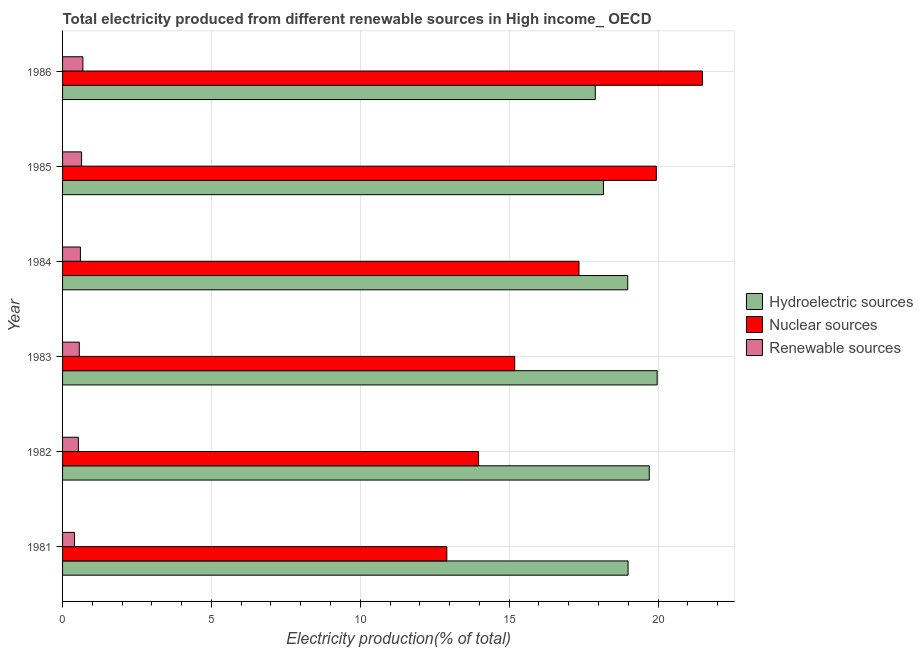How many different coloured bars are there?
Provide a short and direct response. 3. How many groups of bars are there?
Provide a succinct answer. 6. Are the number of bars on each tick of the Y-axis equal?
Provide a succinct answer. Yes. What is the label of the 3rd group of bars from the top?
Ensure brevity in your answer.  1984. In how many cases, is the number of bars for a given year not equal to the number of legend labels?
Make the answer very short. 0. What is the percentage of electricity produced by hydroelectric sources in 1984?
Provide a succinct answer. 18.98. Across all years, what is the maximum percentage of electricity produced by hydroelectric sources?
Your answer should be compact. 19.97. Across all years, what is the minimum percentage of electricity produced by renewable sources?
Provide a short and direct response. 0.4. What is the total percentage of electricity produced by renewable sources in the graph?
Make the answer very short. 3.41. What is the difference between the percentage of electricity produced by nuclear sources in 1981 and that in 1985?
Your response must be concise. -7.04. What is the difference between the percentage of electricity produced by nuclear sources in 1984 and the percentage of electricity produced by hydroelectric sources in 1983?
Your response must be concise. -2.63. What is the average percentage of electricity produced by renewable sources per year?
Your response must be concise. 0.57. In the year 1982, what is the difference between the percentage of electricity produced by renewable sources and percentage of electricity produced by hydroelectric sources?
Keep it short and to the point. -19.17. What is the ratio of the percentage of electricity produced by nuclear sources in 1981 to that in 1982?
Provide a short and direct response. 0.92. What is the difference between the highest and the second highest percentage of electricity produced by hydroelectric sources?
Your answer should be very brief. 0.27. What is the difference between the highest and the lowest percentage of electricity produced by hydroelectric sources?
Offer a very short reply. 2.08. What does the 1st bar from the top in 1986 represents?
Your response must be concise. Renewable sources. What does the 3rd bar from the bottom in 1981 represents?
Provide a short and direct response. Renewable sources. Is it the case that in every year, the sum of the percentage of electricity produced by hydroelectric sources and percentage of electricity produced by nuclear sources is greater than the percentage of electricity produced by renewable sources?
Your answer should be very brief. Yes. How many bars are there?
Make the answer very short. 18. Are all the bars in the graph horizontal?
Provide a short and direct response. Yes. How many years are there in the graph?
Give a very brief answer. 6. What is the difference between two consecutive major ticks on the X-axis?
Your answer should be very brief. 5. Are the values on the major ticks of X-axis written in scientific E-notation?
Make the answer very short. No. Does the graph contain grids?
Your answer should be very brief. Yes. How many legend labels are there?
Provide a short and direct response. 3. How are the legend labels stacked?
Offer a very short reply. Vertical. What is the title of the graph?
Offer a very short reply. Total electricity produced from different renewable sources in High income_ OECD. Does "Taxes on goods and services" appear as one of the legend labels in the graph?
Make the answer very short. No. What is the Electricity production(% of total) in Hydroelectric sources in 1981?
Your answer should be very brief. 18.99. What is the Electricity production(% of total) of Nuclear sources in 1981?
Your answer should be very brief. 12.91. What is the Electricity production(% of total) in Renewable sources in 1981?
Give a very brief answer. 0.4. What is the Electricity production(% of total) of Hydroelectric sources in 1982?
Your response must be concise. 19.7. What is the Electricity production(% of total) of Nuclear sources in 1982?
Offer a very short reply. 13.97. What is the Electricity production(% of total) in Renewable sources in 1982?
Your response must be concise. 0.53. What is the Electricity production(% of total) of Hydroelectric sources in 1983?
Your response must be concise. 19.97. What is the Electricity production(% of total) in Nuclear sources in 1983?
Provide a succinct answer. 15.19. What is the Electricity production(% of total) of Renewable sources in 1983?
Offer a terse response. 0.56. What is the Electricity production(% of total) in Hydroelectric sources in 1984?
Your response must be concise. 18.98. What is the Electricity production(% of total) in Nuclear sources in 1984?
Ensure brevity in your answer.  17.34. What is the Electricity production(% of total) in Renewable sources in 1984?
Make the answer very short. 0.6. What is the Electricity production(% of total) of Hydroelectric sources in 1985?
Keep it short and to the point. 18.17. What is the Electricity production(% of total) in Nuclear sources in 1985?
Provide a succinct answer. 19.94. What is the Electricity production(% of total) of Renewable sources in 1985?
Your response must be concise. 0.64. What is the Electricity production(% of total) of Hydroelectric sources in 1986?
Your answer should be compact. 17.89. What is the Electricity production(% of total) of Nuclear sources in 1986?
Offer a terse response. 21.49. What is the Electricity production(% of total) of Renewable sources in 1986?
Offer a terse response. 0.68. Across all years, what is the maximum Electricity production(% of total) of Hydroelectric sources?
Make the answer very short. 19.97. Across all years, what is the maximum Electricity production(% of total) in Nuclear sources?
Your answer should be very brief. 21.49. Across all years, what is the maximum Electricity production(% of total) in Renewable sources?
Keep it short and to the point. 0.68. Across all years, what is the minimum Electricity production(% of total) of Hydroelectric sources?
Provide a short and direct response. 17.89. Across all years, what is the minimum Electricity production(% of total) of Nuclear sources?
Provide a succinct answer. 12.91. Across all years, what is the minimum Electricity production(% of total) in Renewable sources?
Keep it short and to the point. 0.4. What is the total Electricity production(% of total) in Hydroelectric sources in the graph?
Offer a very short reply. 113.71. What is the total Electricity production(% of total) of Nuclear sources in the graph?
Provide a succinct answer. 100.84. What is the total Electricity production(% of total) of Renewable sources in the graph?
Your response must be concise. 3.41. What is the difference between the Electricity production(% of total) of Hydroelectric sources in 1981 and that in 1982?
Provide a short and direct response. -0.71. What is the difference between the Electricity production(% of total) in Nuclear sources in 1981 and that in 1982?
Provide a succinct answer. -1.07. What is the difference between the Electricity production(% of total) in Renewable sources in 1981 and that in 1982?
Your answer should be compact. -0.13. What is the difference between the Electricity production(% of total) in Hydroelectric sources in 1981 and that in 1983?
Give a very brief answer. -0.98. What is the difference between the Electricity production(% of total) in Nuclear sources in 1981 and that in 1983?
Your answer should be very brief. -2.28. What is the difference between the Electricity production(% of total) of Renewable sources in 1981 and that in 1983?
Provide a succinct answer. -0.16. What is the difference between the Electricity production(% of total) of Hydroelectric sources in 1981 and that in 1984?
Keep it short and to the point. 0.01. What is the difference between the Electricity production(% of total) of Nuclear sources in 1981 and that in 1984?
Provide a short and direct response. -4.44. What is the difference between the Electricity production(% of total) of Renewable sources in 1981 and that in 1984?
Offer a terse response. -0.2. What is the difference between the Electricity production(% of total) in Hydroelectric sources in 1981 and that in 1985?
Your answer should be compact. 0.83. What is the difference between the Electricity production(% of total) of Nuclear sources in 1981 and that in 1985?
Your answer should be very brief. -7.04. What is the difference between the Electricity production(% of total) in Renewable sources in 1981 and that in 1985?
Provide a succinct answer. -0.24. What is the difference between the Electricity production(% of total) of Hydroelectric sources in 1981 and that in 1986?
Ensure brevity in your answer.  1.1. What is the difference between the Electricity production(% of total) of Nuclear sources in 1981 and that in 1986?
Keep it short and to the point. -8.59. What is the difference between the Electricity production(% of total) of Renewable sources in 1981 and that in 1986?
Your response must be concise. -0.28. What is the difference between the Electricity production(% of total) of Hydroelectric sources in 1982 and that in 1983?
Offer a terse response. -0.27. What is the difference between the Electricity production(% of total) of Nuclear sources in 1982 and that in 1983?
Your response must be concise. -1.21. What is the difference between the Electricity production(% of total) in Renewable sources in 1982 and that in 1983?
Offer a terse response. -0.03. What is the difference between the Electricity production(% of total) of Hydroelectric sources in 1982 and that in 1984?
Make the answer very short. 0.72. What is the difference between the Electricity production(% of total) of Nuclear sources in 1982 and that in 1984?
Your answer should be very brief. -3.37. What is the difference between the Electricity production(% of total) of Renewable sources in 1982 and that in 1984?
Provide a succinct answer. -0.07. What is the difference between the Electricity production(% of total) in Hydroelectric sources in 1982 and that in 1985?
Ensure brevity in your answer.  1.54. What is the difference between the Electricity production(% of total) in Nuclear sources in 1982 and that in 1985?
Offer a very short reply. -5.97. What is the difference between the Electricity production(% of total) in Renewable sources in 1982 and that in 1985?
Provide a short and direct response. -0.11. What is the difference between the Electricity production(% of total) in Hydroelectric sources in 1982 and that in 1986?
Provide a short and direct response. 1.81. What is the difference between the Electricity production(% of total) in Nuclear sources in 1982 and that in 1986?
Your answer should be very brief. -7.52. What is the difference between the Electricity production(% of total) in Renewable sources in 1982 and that in 1986?
Make the answer very short. -0.15. What is the difference between the Electricity production(% of total) of Hydroelectric sources in 1983 and that in 1984?
Offer a terse response. 0.99. What is the difference between the Electricity production(% of total) of Nuclear sources in 1983 and that in 1984?
Your answer should be very brief. -2.16. What is the difference between the Electricity production(% of total) of Renewable sources in 1983 and that in 1984?
Your answer should be compact. -0.04. What is the difference between the Electricity production(% of total) in Hydroelectric sources in 1983 and that in 1985?
Keep it short and to the point. 1.8. What is the difference between the Electricity production(% of total) of Nuclear sources in 1983 and that in 1985?
Give a very brief answer. -4.76. What is the difference between the Electricity production(% of total) in Renewable sources in 1983 and that in 1985?
Offer a very short reply. -0.08. What is the difference between the Electricity production(% of total) of Hydroelectric sources in 1983 and that in 1986?
Give a very brief answer. 2.08. What is the difference between the Electricity production(% of total) of Nuclear sources in 1983 and that in 1986?
Your answer should be compact. -6.3. What is the difference between the Electricity production(% of total) of Renewable sources in 1983 and that in 1986?
Give a very brief answer. -0.12. What is the difference between the Electricity production(% of total) of Hydroelectric sources in 1984 and that in 1985?
Keep it short and to the point. 0.82. What is the difference between the Electricity production(% of total) of Nuclear sources in 1984 and that in 1985?
Give a very brief answer. -2.6. What is the difference between the Electricity production(% of total) of Renewable sources in 1984 and that in 1985?
Give a very brief answer. -0.04. What is the difference between the Electricity production(% of total) in Hydroelectric sources in 1984 and that in 1986?
Provide a succinct answer. 1.09. What is the difference between the Electricity production(% of total) of Nuclear sources in 1984 and that in 1986?
Your response must be concise. -4.15. What is the difference between the Electricity production(% of total) of Renewable sources in 1984 and that in 1986?
Your answer should be very brief. -0.08. What is the difference between the Electricity production(% of total) of Hydroelectric sources in 1985 and that in 1986?
Give a very brief answer. 0.27. What is the difference between the Electricity production(% of total) of Nuclear sources in 1985 and that in 1986?
Provide a succinct answer. -1.55. What is the difference between the Electricity production(% of total) of Renewable sources in 1985 and that in 1986?
Your answer should be very brief. -0.04. What is the difference between the Electricity production(% of total) in Hydroelectric sources in 1981 and the Electricity production(% of total) in Nuclear sources in 1982?
Offer a terse response. 5.02. What is the difference between the Electricity production(% of total) of Hydroelectric sources in 1981 and the Electricity production(% of total) of Renewable sources in 1982?
Keep it short and to the point. 18.46. What is the difference between the Electricity production(% of total) in Nuclear sources in 1981 and the Electricity production(% of total) in Renewable sources in 1982?
Your response must be concise. 12.38. What is the difference between the Electricity production(% of total) of Hydroelectric sources in 1981 and the Electricity production(% of total) of Nuclear sources in 1983?
Offer a terse response. 3.81. What is the difference between the Electricity production(% of total) in Hydroelectric sources in 1981 and the Electricity production(% of total) in Renewable sources in 1983?
Give a very brief answer. 18.43. What is the difference between the Electricity production(% of total) in Nuclear sources in 1981 and the Electricity production(% of total) in Renewable sources in 1983?
Give a very brief answer. 12.34. What is the difference between the Electricity production(% of total) of Hydroelectric sources in 1981 and the Electricity production(% of total) of Nuclear sources in 1984?
Offer a very short reply. 1.65. What is the difference between the Electricity production(% of total) in Hydroelectric sources in 1981 and the Electricity production(% of total) in Renewable sources in 1984?
Offer a very short reply. 18.39. What is the difference between the Electricity production(% of total) in Nuclear sources in 1981 and the Electricity production(% of total) in Renewable sources in 1984?
Provide a succinct answer. 12.31. What is the difference between the Electricity production(% of total) in Hydroelectric sources in 1981 and the Electricity production(% of total) in Nuclear sources in 1985?
Make the answer very short. -0.95. What is the difference between the Electricity production(% of total) in Hydroelectric sources in 1981 and the Electricity production(% of total) in Renewable sources in 1985?
Give a very brief answer. 18.35. What is the difference between the Electricity production(% of total) in Nuclear sources in 1981 and the Electricity production(% of total) in Renewable sources in 1985?
Ensure brevity in your answer.  12.27. What is the difference between the Electricity production(% of total) of Hydroelectric sources in 1981 and the Electricity production(% of total) of Nuclear sources in 1986?
Provide a short and direct response. -2.5. What is the difference between the Electricity production(% of total) in Hydroelectric sources in 1981 and the Electricity production(% of total) in Renewable sources in 1986?
Give a very brief answer. 18.31. What is the difference between the Electricity production(% of total) of Nuclear sources in 1981 and the Electricity production(% of total) of Renewable sources in 1986?
Your answer should be very brief. 12.22. What is the difference between the Electricity production(% of total) of Hydroelectric sources in 1982 and the Electricity production(% of total) of Nuclear sources in 1983?
Your answer should be compact. 4.52. What is the difference between the Electricity production(% of total) in Hydroelectric sources in 1982 and the Electricity production(% of total) in Renewable sources in 1983?
Provide a short and direct response. 19.14. What is the difference between the Electricity production(% of total) in Nuclear sources in 1982 and the Electricity production(% of total) in Renewable sources in 1983?
Make the answer very short. 13.41. What is the difference between the Electricity production(% of total) in Hydroelectric sources in 1982 and the Electricity production(% of total) in Nuclear sources in 1984?
Provide a succinct answer. 2.36. What is the difference between the Electricity production(% of total) in Hydroelectric sources in 1982 and the Electricity production(% of total) in Renewable sources in 1984?
Ensure brevity in your answer.  19.11. What is the difference between the Electricity production(% of total) in Nuclear sources in 1982 and the Electricity production(% of total) in Renewable sources in 1984?
Your answer should be very brief. 13.37. What is the difference between the Electricity production(% of total) of Hydroelectric sources in 1982 and the Electricity production(% of total) of Nuclear sources in 1985?
Ensure brevity in your answer.  -0.24. What is the difference between the Electricity production(% of total) in Hydroelectric sources in 1982 and the Electricity production(% of total) in Renewable sources in 1985?
Keep it short and to the point. 19.07. What is the difference between the Electricity production(% of total) in Nuclear sources in 1982 and the Electricity production(% of total) in Renewable sources in 1985?
Your answer should be very brief. 13.33. What is the difference between the Electricity production(% of total) of Hydroelectric sources in 1982 and the Electricity production(% of total) of Nuclear sources in 1986?
Your answer should be very brief. -1.79. What is the difference between the Electricity production(% of total) of Hydroelectric sources in 1982 and the Electricity production(% of total) of Renewable sources in 1986?
Provide a succinct answer. 19.02. What is the difference between the Electricity production(% of total) of Nuclear sources in 1982 and the Electricity production(% of total) of Renewable sources in 1986?
Ensure brevity in your answer.  13.29. What is the difference between the Electricity production(% of total) in Hydroelectric sources in 1983 and the Electricity production(% of total) in Nuclear sources in 1984?
Give a very brief answer. 2.63. What is the difference between the Electricity production(% of total) of Hydroelectric sources in 1983 and the Electricity production(% of total) of Renewable sources in 1984?
Your answer should be very brief. 19.37. What is the difference between the Electricity production(% of total) of Nuclear sources in 1983 and the Electricity production(% of total) of Renewable sources in 1984?
Keep it short and to the point. 14.59. What is the difference between the Electricity production(% of total) of Hydroelectric sources in 1983 and the Electricity production(% of total) of Nuclear sources in 1985?
Ensure brevity in your answer.  0.03. What is the difference between the Electricity production(% of total) in Hydroelectric sources in 1983 and the Electricity production(% of total) in Renewable sources in 1985?
Offer a very short reply. 19.33. What is the difference between the Electricity production(% of total) in Nuclear sources in 1983 and the Electricity production(% of total) in Renewable sources in 1985?
Your response must be concise. 14.55. What is the difference between the Electricity production(% of total) in Hydroelectric sources in 1983 and the Electricity production(% of total) in Nuclear sources in 1986?
Give a very brief answer. -1.52. What is the difference between the Electricity production(% of total) of Hydroelectric sources in 1983 and the Electricity production(% of total) of Renewable sources in 1986?
Offer a terse response. 19.29. What is the difference between the Electricity production(% of total) in Nuclear sources in 1983 and the Electricity production(% of total) in Renewable sources in 1986?
Your answer should be very brief. 14.5. What is the difference between the Electricity production(% of total) in Hydroelectric sources in 1984 and the Electricity production(% of total) in Nuclear sources in 1985?
Your response must be concise. -0.96. What is the difference between the Electricity production(% of total) of Hydroelectric sources in 1984 and the Electricity production(% of total) of Renewable sources in 1985?
Offer a very short reply. 18.34. What is the difference between the Electricity production(% of total) in Nuclear sources in 1984 and the Electricity production(% of total) in Renewable sources in 1985?
Your response must be concise. 16.71. What is the difference between the Electricity production(% of total) of Hydroelectric sources in 1984 and the Electricity production(% of total) of Nuclear sources in 1986?
Your answer should be very brief. -2.51. What is the difference between the Electricity production(% of total) in Hydroelectric sources in 1984 and the Electricity production(% of total) in Renewable sources in 1986?
Offer a terse response. 18.3. What is the difference between the Electricity production(% of total) in Nuclear sources in 1984 and the Electricity production(% of total) in Renewable sources in 1986?
Give a very brief answer. 16.66. What is the difference between the Electricity production(% of total) of Hydroelectric sources in 1985 and the Electricity production(% of total) of Nuclear sources in 1986?
Keep it short and to the point. -3.32. What is the difference between the Electricity production(% of total) in Hydroelectric sources in 1985 and the Electricity production(% of total) in Renewable sources in 1986?
Make the answer very short. 17.48. What is the difference between the Electricity production(% of total) in Nuclear sources in 1985 and the Electricity production(% of total) in Renewable sources in 1986?
Provide a short and direct response. 19.26. What is the average Electricity production(% of total) in Hydroelectric sources per year?
Your answer should be compact. 18.95. What is the average Electricity production(% of total) in Nuclear sources per year?
Your answer should be very brief. 16.81. What is the average Electricity production(% of total) in Renewable sources per year?
Your response must be concise. 0.57. In the year 1981, what is the difference between the Electricity production(% of total) of Hydroelectric sources and Electricity production(% of total) of Nuclear sources?
Offer a terse response. 6.09. In the year 1981, what is the difference between the Electricity production(% of total) of Hydroelectric sources and Electricity production(% of total) of Renewable sources?
Offer a terse response. 18.59. In the year 1981, what is the difference between the Electricity production(% of total) of Nuclear sources and Electricity production(% of total) of Renewable sources?
Your response must be concise. 12.5. In the year 1982, what is the difference between the Electricity production(% of total) of Hydroelectric sources and Electricity production(% of total) of Nuclear sources?
Offer a terse response. 5.73. In the year 1982, what is the difference between the Electricity production(% of total) in Hydroelectric sources and Electricity production(% of total) in Renewable sources?
Your answer should be very brief. 19.17. In the year 1982, what is the difference between the Electricity production(% of total) in Nuclear sources and Electricity production(% of total) in Renewable sources?
Keep it short and to the point. 13.44. In the year 1983, what is the difference between the Electricity production(% of total) in Hydroelectric sources and Electricity production(% of total) in Nuclear sources?
Offer a terse response. 4.78. In the year 1983, what is the difference between the Electricity production(% of total) of Hydroelectric sources and Electricity production(% of total) of Renewable sources?
Your answer should be compact. 19.41. In the year 1983, what is the difference between the Electricity production(% of total) of Nuclear sources and Electricity production(% of total) of Renewable sources?
Offer a terse response. 14.62. In the year 1984, what is the difference between the Electricity production(% of total) in Hydroelectric sources and Electricity production(% of total) in Nuclear sources?
Keep it short and to the point. 1.64. In the year 1984, what is the difference between the Electricity production(% of total) of Hydroelectric sources and Electricity production(% of total) of Renewable sources?
Ensure brevity in your answer.  18.38. In the year 1984, what is the difference between the Electricity production(% of total) of Nuclear sources and Electricity production(% of total) of Renewable sources?
Ensure brevity in your answer.  16.74. In the year 1985, what is the difference between the Electricity production(% of total) of Hydroelectric sources and Electricity production(% of total) of Nuclear sources?
Make the answer very short. -1.78. In the year 1985, what is the difference between the Electricity production(% of total) in Hydroelectric sources and Electricity production(% of total) in Renewable sources?
Keep it short and to the point. 17.53. In the year 1985, what is the difference between the Electricity production(% of total) of Nuclear sources and Electricity production(% of total) of Renewable sources?
Your answer should be compact. 19.3. In the year 1986, what is the difference between the Electricity production(% of total) in Hydroelectric sources and Electricity production(% of total) in Nuclear sources?
Your response must be concise. -3.6. In the year 1986, what is the difference between the Electricity production(% of total) in Hydroelectric sources and Electricity production(% of total) in Renewable sources?
Keep it short and to the point. 17.21. In the year 1986, what is the difference between the Electricity production(% of total) of Nuclear sources and Electricity production(% of total) of Renewable sources?
Keep it short and to the point. 20.81. What is the ratio of the Electricity production(% of total) in Hydroelectric sources in 1981 to that in 1982?
Your response must be concise. 0.96. What is the ratio of the Electricity production(% of total) of Nuclear sources in 1981 to that in 1982?
Make the answer very short. 0.92. What is the ratio of the Electricity production(% of total) of Renewable sources in 1981 to that in 1982?
Offer a very short reply. 0.76. What is the ratio of the Electricity production(% of total) of Hydroelectric sources in 1981 to that in 1983?
Your answer should be compact. 0.95. What is the ratio of the Electricity production(% of total) in Nuclear sources in 1981 to that in 1983?
Make the answer very short. 0.85. What is the ratio of the Electricity production(% of total) of Renewable sources in 1981 to that in 1983?
Keep it short and to the point. 0.72. What is the ratio of the Electricity production(% of total) of Hydroelectric sources in 1981 to that in 1984?
Your answer should be very brief. 1. What is the ratio of the Electricity production(% of total) in Nuclear sources in 1981 to that in 1984?
Keep it short and to the point. 0.74. What is the ratio of the Electricity production(% of total) in Renewable sources in 1981 to that in 1984?
Give a very brief answer. 0.67. What is the ratio of the Electricity production(% of total) of Hydroelectric sources in 1981 to that in 1985?
Ensure brevity in your answer.  1.05. What is the ratio of the Electricity production(% of total) in Nuclear sources in 1981 to that in 1985?
Ensure brevity in your answer.  0.65. What is the ratio of the Electricity production(% of total) in Renewable sources in 1981 to that in 1985?
Provide a short and direct response. 0.63. What is the ratio of the Electricity production(% of total) in Hydroelectric sources in 1981 to that in 1986?
Your answer should be very brief. 1.06. What is the ratio of the Electricity production(% of total) of Nuclear sources in 1981 to that in 1986?
Ensure brevity in your answer.  0.6. What is the ratio of the Electricity production(% of total) of Renewable sources in 1981 to that in 1986?
Your answer should be very brief. 0.59. What is the ratio of the Electricity production(% of total) in Hydroelectric sources in 1982 to that in 1983?
Provide a succinct answer. 0.99. What is the ratio of the Electricity production(% of total) of Nuclear sources in 1982 to that in 1983?
Offer a very short reply. 0.92. What is the ratio of the Electricity production(% of total) of Renewable sources in 1982 to that in 1983?
Give a very brief answer. 0.95. What is the ratio of the Electricity production(% of total) of Hydroelectric sources in 1982 to that in 1984?
Your answer should be compact. 1.04. What is the ratio of the Electricity production(% of total) of Nuclear sources in 1982 to that in 1984?
Give a very brief answer. 0.81. What is the ratio of the Electricity production(% of total) of Renewable sources in 1982 to that in 1984?
Ensure brevity in your answer.  0.89. What is the ratio of the Electricity production(% of total) in Hydroelectric sources in 1982 to that in 1985?
Make the answer very short. 1.08. What is the ratio of the Electricity production(% of total) in Nuclear sources in 1982 to that in 1985?
Give a very brief answer. 0.7. What is the ratio of the Electricity production(% of total) in Renewable sources in 1982 to that in 1985?
Give a very brief answer. 0.83. What is the ratio of the Electricity production(% of total) in Hydroelectric sources in 1982 to that in 1986?
Make the answer very short. 1.1. What is the ratio of the Electricity production(% of total) in Nuclear sources in 1982 to that in 1986?
Offer a terse response. 0.65. What is the ratio of the Electricity production(% of total) of Renewable sources in 1982 to that in 1986?
Offer a very short reply. 0.78. What is the ratio of the Electricity production(% of total) in Hydroelectric sources in 1983 to that in 1984?
Your answer should be compact. 1.05. What is the ratio of the Electricity production(% of total) in Nuclear sources in 1983 to that in 1984?
Offer a terse response. 0.88. What is the ratio of the Electricity production(% of total) in Renewable sources in 1983 to that in 1984?
Your answer should be very brief. 0.94. What is the ratio of the Electricity production(% of total) of Hydroelectric sources in 1983 to that in 1985?
Provide a short and direct response. 1.1. What is the ratio of the Electricity production(% of total) in Nuclear sources in 1983 to that in 1985?
Your answer should be compact. 0.76. What is the ratio of the Electricity production(% of total) in Renewable sources in 1983 to that in 1985?
Give a very brief answer. 0.88. What is the ratio of the Electricity production(% of total) in Hydroelectric sources in 1983 to that in 1986?
Give a very brief answer. 1.12. What is the ratio of the Electricity production(% of total) of Nuclear sources in 1983 to that in 1986?
Ensure brevity in your answer.  0.71. What is the ratio of the Electricity production(% of total) in Renewable sources in 1983 to that in 1986?
Your response must be concise. 0.82. What is the ratio of the Electricity production(% of total) in Hydroelectric sources in 1984 to that in 1985?
Keep it short and to the point. 1.04. What is the ratio of the Electricity production(% of total) of Nuclear sources in 1984 to that in 1985?
Your response must be concise. 0.87. What is the ratio of the Electricity production(% of total) in Renewable sources in 1984 to that in 1985?
Your response must be concise. 0.94. What is the ratio of the Electricity production(% of total) of Hydroelectric sources in 1984 to that in 1986?
Give a very brief answer. 1.06. What is the ratio of the Electricity production(% of total) of Nuclear sources in 1984 to that in 1986?
Offer a terse response. 0.81. What is the ratio of the Electricity production(% of total) in Renewable sources in 1984 to that in 1986?
Offer a terse response. 0.88. What is the ratio of the Electricity production(% of total) in Hydroelectric sources in 1985 to that in 1986?
Ensure brevity in your answer.  1.02. What is the ratio of the Electricity production(% of total) in Nuclear sources in 1985 to that in 1986?
Provide a succinct answer. 0.93. What is the ratio of the Electricity production(% of total) of Renewable sources in 1985 to that in 1986?
Make the answer very short. 0.94. What is the difference between the highest and the second highest Electricity production(% of total) of Hydroelectric sources?
Make the answer very short. 0.27. What is the difference between the highest and the second highest Electricity production(% of total) of Nuclear sources?
Your answer should be very brief. 1.55. What is the difference between the highest and the second highest Electricity production(% of total) of Renewable sources?
Your answer should be very brief. 0.04. What is the difference between the highest and the lowest Electricity production(% of total) in Hydroelectric sources?
Give a very brief answer. 2.08. What is the difference between the highest and the lowest Electricity production(% of total) in Nuclear sources?
Give a very brief answer. 8.59. What is the difference between the highest and the lowest Electricity production(% of total) in Renewable sources?
Make the answer very short. 0.28. 